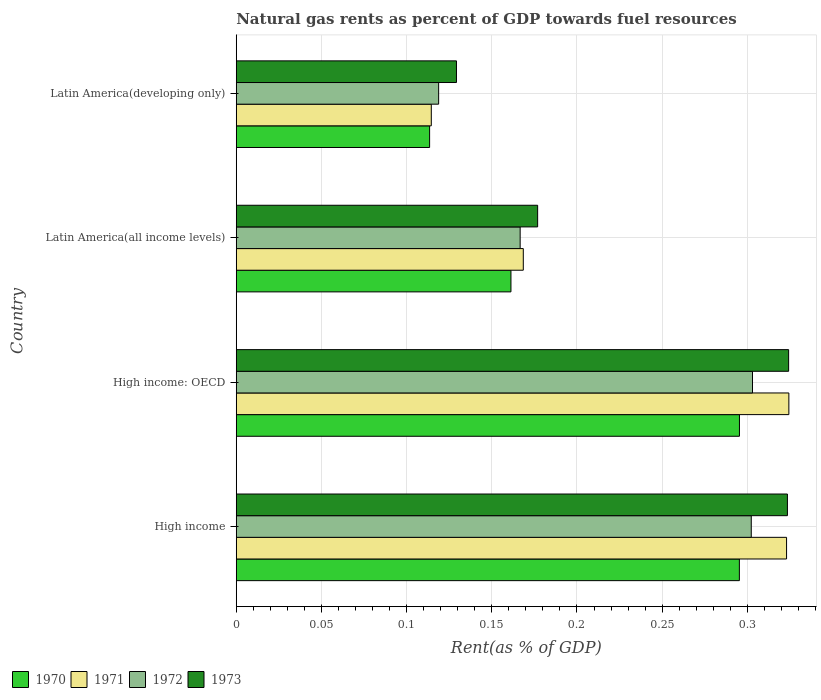How many different coloured bars are there?
Ensure brevity in your answer.  4. How many groups of bars are there?
Provide a succinct answer. 4. Are the number of bars on each tick of the Y-axis equal?
Your answer should be compact. Yes. How many bars are there on the 1st tick from the top?
Keep it short and to the point. 4. How many bars are there on the 4th tick from the bottom?
Your answer should be very brief. 4. In how many cases, is the number of bars for a given country not equal to the number of legend labels?
Make the answer very short. 0. What is the matural gas rent in 1970 in High income: OECD?
Your answer should be compact. 0.3. Across all countries, what is the maximum matural gas rent in 1972?
Make the answer very short. 0.3. Across all countries, what is the minimum matural gas rent in 1970?
Make the answer very short. 0.11. In which country was the matural gas rent in 1973 maximum?
Ensure brevity in your answer.  High income: OECD. In which country was the matural gas rent in 1970 minimum?
Your answer should be compact. Latin America(developing only). What is the total matural gas rent in 1972 in the graph?
Give a very brief answer. 0.89. What is the difference between the matural gas rent in 1972 in High income and that in Latin America(developing only)?
Your response must be concise. 0.18. What is the difference between the matural gas rent in 1972 in Latin America(all income levels) and the matural gas rent in 1971 in High income: OECD?
Your response must be concise. -0.16. What is the average matural gas rent in 1972 per country?
Keep it short and to the point. 0.22. What is the difference between the matural gas rent in 1970 and matural gas rent in 1971 in Latin America(developing only)?
Provide a succinct answer. -0. In how many countries, is the matural gas rent in 1971 greater than 0.28 %?
Provide a succinct answer. 2. What is the ratio of the matural gas rent in 1970 in High income to that in Latin America(developing only)?
Offer a very short reply. 2.6. Is the matural gas rent in 1971 in High income less than that in High income: OECD?
Keep it short and to the point. Yes. Is the difference between the matural gas rent in 1970 in High income: OECD and Latin America(developing only) greater than the difference between the matural gas rent in 1971 in High income: OECD and Latin America(developing only)?
Your answer should be compact. No. What is the difference between the highest and the second highest matural gas rent in 1973?
Your response must be concise. 0. What is the difference between the highest and the lowest matural gas rent in 1972?
Make the answer very short. 0.18. Is the sum of the matural gas rent in 1973 in High income and High income: OECD greater than the maximum matural gas rent in 1972 across all countries?
Offer a terse response. Yes. How many countries are there in the graph?
Your answer should be very brief. 4. Are the values on the major ticks of X-axis written in scientific E-notation?
Your answer should be compact. No. Does the graph contain any zero values?
Provide a succinct answer. No. Does the graph contain grids?
Give a very brief answer. Yes. How are the legend labels stacked?
Make the answer very short. Horizontal. What is the title of the graph?
Keep it short and to the point. Natural gas rents as percent of GDP towards fuel resources. Does "2013" appear as one of the legend labels in the graph?
Provide a succinct answer. No. What is the label or title of the X-axis?
Your response must be concise. Rent(as % of GDP). What is the label or title of the Y-axis?
Your answer should be very brief. Country. What is the Rent(as % of GDP) in 1970 in High income?
Provide a short and direct response. 0.3. What is the Rent(as % of GDP) in 1971 in High income?
Give a very brief answer. 0.32. What is the Rent(as % of GDP) in 1972 in High income?
Your response must be concise. 0.3. What is the Rent(as % of GDP) in 1973 in High income?
Give a very brief answer. 0.32. What is the Rent(as % of GDP) of 1970 in High income: OECD?
Make the answer very short. 0.3. What is the Rent(as % of GDP) of 1971 in High income: OECD?
Make the answer very short. 0.32. What is the Rent(as % of GDP) of 1972 in High income: OECD?
Ensure brevity in your answer.  0.3. What is the Rent(as % of GDP) in 1973 in High income: OECD?
Keep it short and to the point. 0.32. What is the Rent(as % of GDP) of 1970 in Latin America(all income levels)?
Provide a short and direct response. 0.16. What is the Rent(as % of GDP) in 1971 in Latin America(all income levels)?
Offer a terse response. 0.17. What is the Rent(as % of GDP) in 1972 in Latin America(all income levels)?
Make the answer very short. 0.17. What is the Rent(as % of GDP) of 1973 in Latin America(all income levels)?
Offer a terse response. 0.18. What is the Rent(as % of GDP) of 1970 in Latin America(developing only)?
Your answer should be very brief. 0.11. What is the Rent(as % of GDP) of 1971 in Latin America(developing only)?
Provide a short and direct response. 0.11. What is the Rent(as % of GDP) in 1972 in Latin America(developing only)?
Make the answer very short. 0.12. What is the Rent(as % of GDP) in 1973 in Latin America(developing only)?
Offer a terse response. 0.13. Across all countries, what is the maximum Rent(as % of GDP) in 1970?
Provide a short and direct response. 0.3. Across all countries, what is the maximum Rent(as % of GDP) in 1971?
Give a very brief answer. 0.32. Across all countries, what is the maximum Rent(as % of GDP) in 1972?
Your answer should be compact. 0.3. Across all countries, what is the maximum Rent(as % of GDP) of 1973?
Your response must be concise. 0.32. Across all countries, what is the minimum Rent(as % of GDP) of 1970?
Provide a succinct answer. 0.11. Across all countries, what is the minimum Rent(as % of GDP) in 1971?
Provide a succinct answer. 0.11. Across all countries, what is the minimum Rent(as % of GDP) of 1972?
Ensure brevity in your answer.  0.12. Across all countries, what is the minimum Rent(as % of GDP) of 1973?
Ensure brevity in your answer.  0.13. What is the total Rent(as % of GDP) of 1970 in the graph?
Provide a short and direct response. 0.87. What is the total Rent(as % of GDP) of 1971 in the graph?
Make the answer very short. 0.93. What is the total Rent(as % of GDP) of 1972 in the graph?
Offer a very short reply. 0.89. What is the total Rent(as % of GDP) of 1973 in the graph?
Offer a very short reply. 0.95. What is the difference between the Rent(as % of GDP) in 1971 in High income and that in High income: OECD?
Offer a terse response. -0. What is the difference between the Rent(as % of GDP) of 1972 in High income and that in High income: OECD?
Provide a succinct answer. -0. What is the difference between the Rent(as % of GDP) of 1973 in High income and that in High income: OECD?
Your response must be concise. -0. What is the difference between the Rent(as % of GDP) of 1970 in High income and that in Latin America(all income levels)?
Offer a very short reply. 0.13. What is the difference between the Rent(as % of GDP) in 1971 in High income and that in Latin America(all income levels)?
Your response must be concise. 0.15. What is the difference between the Rent(as % of GDP) of 1972 in High income and that in Latin America(all income levels)?
Make the answer very short. 0.14. What is the difference between the Rent(as % of GDP) of 1973 in High income and that in Latin America(all income levels)?
Ensure brevity in your answer.  0.15. What is the difference between the Rent(as % of GDP) of 1970 in High income and that in Latin America(developing only)?
Ensure brevity in your answer.  0.18. What is the difference between the Rent(as % of GDP) of 1971 in High income and that in Latin America(developing only)?
Offer a terse response. 0.21. What is the difference between the Rent(as % of GDP) of 1972 in High income and that in Latin America(developing only)?
Provide a short and direct response. 0.18. What is the difference between the Rent(as % of GDP) in 1973 in High income and that in Latin America(developing only)?
Make the answer very short. 0.19. What is the difference between the Rent(as % of GDP) of 1970 in High income: OECD and that in Latin America(all income levels)?
Give a very brief answer. 0.13. What is the difference between the Rent(as % of GDP) in 1971 in High income: OECD and that in Latin America(all income levels)?
Provide a short and direct response. 0.16. What is the difference between the Rent(as % of GDP) of 1972 in High income: OECD and that in Latin America(all income levels)?
Provide a short and direct response. 0.14. What is the difference between the Rent(as % of GDP) in 1973 in High income: OECD and that in Latin America(all income levels)?
Ensure brevity in your answer.  0.15. What is the difference between the Rent(as % of GDP) of 1970 in High income: OECD and that in Latin America(developing only)?
Make the answer very short. 0.18. What is the difference between the Rent(as % of GDP) of 1971 in High income: OECD and that in Latin America(developing only)?
Ensure brevity in your answer.  0.21. What is the difference between the Rent(as % of GDP) of 1972 in High income: OECD and that in Latin America(developing only)?
Make the answer very short. 0.18. What is the difference between the Rent(as % of GDP) of 1973 in High income: OECD and that in Latin America(developing only)?
Ensure brevity in your answer.  0.2. What is the difference between the Rent(as % of GDP) of 1970 in Latin America(all income levels) and that in Latin America(developing only)?
Make the answer very short. 0.05. What is the difference between the Rent(as % of GDP) of 1971 in Latin America(all income levels) and that in Latin America(developing only)?
Your response must be concise. 0.05. What is the difference between the Rent(as % of GDP) in 1972 in Latin America(all income levels) and that in Latin America(developing only)?
Keep it short and to the point. 0.05. What is the difference between the Rent(as % of GDP) in 1973 in Latin America(all income levels) and that in Latin America(developing only)?
Provide a succinct answer. 0.05. What is the difference between the Rent(as % of GDP) in 1970 in High income and the Rent(as % of GDP) in 1971 in High income: OECD?
Offer a terse response. -0.03. What is the difference between the Rent(as % of GDP) of 1970 in High income and the Rent(as % of GDP) of 1972 in High income: OECD?
Your response must be concise. -0.01. What is the difference between the Rent(as % of GDP) in 1970 in High income and the Rent(as % of GDP) in 1973 in High income: OECD?
Give a very brief answer. -0.03. What is the difference between the Rent(as % of GDP) of 1971 in High income and the Rent(as % of GDP) of 1973 in High income: OECD?
Keep it short and to the point. -0. What is the difference between the Rent(as % of GDP) of 1972 in High income and the Rent(as % of GDP) of 1973 in High income: OECD?
Your response must be concise. -0.02. What is the difference between the Rent(as % of GDP) in 1970 in High income and the Rent(as % of GDP) in 1971 in Latin America(all income levels)?
Provide a short and direct response. 0.13. What is the difference between the Rent(as % of GDP) of 1970 in High income and the Rent(as % of GDP) of 1972 in Latin America(all income levels)?
Provide a short and direct response. 0.13. What is the difference between the Rent(as % of GDP) in 1970 in High income and the Rent(as % of GDP) in 1973 in Latin America(all income levels)?
Your answer should be compact. 0.12. What is the difference between the Rent(as % of GDP) in 1971 in High income and the Rent(as % of GDP) in 1972 in Latin America(all income levels)?
Offer a terse response. 0.16. What is the difference between the Rent(as % of GDP) of 1971 in High income and the Rent(as % of GDP) of 1973 in Latin America(all income levels)?
Offer a very short reply. 0.15. What is the difference between the Rent(as % of GDP) in 1972 in High income and the Rent(as % of GDP) in 1973 in Latin America(all income levels)?
Provide a short and direct response. 0.13. What is the difference between the Rent(as % of GDP) of 1970 in High income and the Rent(as % of GDP) of 1971 in Latin America(developing only)?
Offer a very short reply. 0.18. What is the difference between the Rent(as % of GDP) of 1970 in High income and the Rent(as % of GDP) of 1972 in Latin America(developing only)?
Give a very brief answer. 0.18. What is the difference between the Rent(as % of GDP) in 1970 in High income and the Rent(as % of GDP) in 1973 in Latin America(developing only)?
Offer a terse response. 0.17. What is the difference between the Rent(as % of GDP) in 1971 in High income and the Rent(as % of GDP) in 1972 in Latin America(developing only)?
Your response must be concise. 0.2. What is the difference between the Rent(as % of GDP) of 1971 in High income and the Rent(as % of GDP) of 1973 in Latin America(developing only)?
Provide a succinct answer. 0.19. What is the difference between the Rent(as % of GDP) of 1972 in High income and the Rent(as % of GDP) of 1973 in Latin America(developing only)?
Make the answer very short. 0.17. What is the difference between the Rent(as % of GDP) of 1970 in High income: OECD and the Rent(as % of GDP) of 1971 in Latin America(all income levels)?
Ensure brevity in your answer.  0.13. What is the difference between the Rent(as % of GDP) in 1970 in High income: OECD and the Rent(as % of GDP) in 1972 in Latin America(all income levels)?
Your answer should be very brief. 0.13. What is the difference between the Rent(as % of GDP) in 1970 in High income: OECD and the Rent(as % of GDP) in 1973 in Latin America(all income levels)?
Your answer should be compact. 0.12. What is the difference between the Rent(as % of GDP) of 1971 in High income: OECD and the Rent(as % of GDP) of 1972 in Latin America(all income levels)?
Offer a terse response. 0.16. What is the difference between the Rent(as % of GDP) in 1971 in High income: OECD and the Rent(as % of GDP) in 1973 in Latin America(all income levels)?
Your answer should be compact. 0.15. What is the difference between the Rent(as % of GDP) in 1972 in High income: OECD and the Rent(as % of GDP) in 1973 in Latin America(all income levels)?
Provide a short and direct response. 0.13. What is the difference between the Rent(as % of GDP) in 1970 in High income: OECD and the Rent(as % of GDP) in 1971 in Latin America(developing only)?
Ensure brevity in your answer.  0.18. What is the difference between the Rent(as % of GDP) of 1970 in High income: OECD and the Rent(as % of GDP) of 1972 in Latin America(developing only)?
Keep it short and to the point. 0.18. What is the difference between the Rent(as % of GDP) of 1970 in High income: OECD and the Rent(as % of GDP) of 1973 in Latin America(developing only)?
Offer a very short reply. 0.17. What is the difference between the Rent(as % of GDP) of 1971 in High income: OECD and the Rent(as % of GDP) of 1972 in Latin America(developing only)?
Your answer should be compact. 0.21. What is the difference between the Rent(as % of GDP) in 1971 in High income: OECD and the Rent(as % of GDP) in 1973 in Latin America(developing only)?
Ensure brevity in your answer.  0.2. What is the difference between the Rent(as % of GDP) in 1972 in High income: OECD and the Rent(as % of GDP) in 1973 in Latin America(developing only)?
Give a very brief answer. 0.17. What is the difference between the Rent(as % of GDP) in 1970 in Latin America(all income levels) and the Rent(as % of GDP) in 1971 in Latin America(developing only)?
Provide a succinct answer. 0.05. What is the difference between the Rent(as % of GDP) in 1970 in Latin America(all income levels) and the Rent(as % of GDP) in 1972 in Latin America(developing only)?
Make the answer very short. 0.04. What is the difference between the Rent(as % of GDP) in 1970 in Latin America(all income levels) and the Rent(as % of GDP) in 1973 in Latin America(developing only)?
Keep it short and to the point. 0.03. What is the difference between the Rent(as % of GDP) of 1971 in Latin America(all income levels) and the Rent(as % of GDP) of 1972 in Latin America(developing only)?
Make the answer very short. 0.05. What is the difference between the Rent(as % of GDP) in 1971 in Latin America(all income levels) and the Rent(as % of GDP) in 1973 in Latin America(developing only)?
Give a very brief answer. 0.04. What is the difference between the Rent(as % of GDP) in 1972 in Latin America(all income levels) and the Rent(as % of GDP) in 1973 in Latin America(developing only)?
Provide a succinct answer. 0.04. What is the average Rent(as % of GDP) of 1970 per country?
Your answer should be very brief. 0.22. What is the average Rent(as % of GDP) of 1971 per country?
Make the answer very short. 0.23. What is the average Rent(as % of GDP) in 1972 per country?
Your answer should be compact. 0.22. What is the average Rent(as % of GDP) in 1973 per country?
Your response must be concise. 0.24. What is the difference between the Rent(as % of GDP) of 1970 and Rent(as % of GDP) of 1971 in High income?
Provide a short and direct response. -0.03. What is the difference between the Rent(as % of GDP) of 1970 and Rent(as % of GDP) of 1972 in High income?
Offer a terse response. -0.01. What is the difference between the Rent(as % of GDP) in 1970 and Rent(as % of GDP) in 1973 in High income?
Keep it short and to the point. -0.03. What is the difference between the Rent(as % of GDP) in 1971 and Rent(as % of GDP) in 1972 in High income?
Offer a very short reply. 0.02. What is the difference between the Rent(as % of GDP) of 1971 and Rent(as % of GDP) of 1973 in High income?
Provide a succinct answer. -0. What is the difference between the Rent(as % of GDP) of 1972 and Rent(as % of GDP) of 1973 in High income?
Offer a very short reply. -0.02. What is the difference between the Rent(as % of GDP) of 1970 and Rent(as % of GDP) of 1971 in High income: OECD?
Ensure brevity in your answer.  -0.03. What is the difference between the Rent(as % of GDP) in 1970 and Rent(as % of GDP) in 1972 in High income: OECD?
Your answer should be very brief. -0.01. What is the difference between the Rent(as % of GDP) in 1970 and Rent(as % of GDP) in 1973 in High income: OECD?
Your answer should be compact. -0.03. What is the difference between the Rent(as % of GDP) of 1971 and Rent(as % of GDP) of 1972 in High income: OECD?
Your answer should be compact. 0.02. What is the difference between the Rent(as % of GDP) of 1971 and Rent(as % of GDP) of 1973 in High income: OECD?
Keep it short and to the point. 0. What is the difference between the Rent(as % of GDP) of 1972 and Rent(as % of GDP) of 1973 in High income: OECD?
Your answer should be compact. -0.02. What is the difference between the Rent(as % of GDP) in 1970 and Rent(as % of GDP) in 1971 in Latin America(all income levels)?
Your answer should be very brief. -0.01. What is the difference between the Rent(as % of GDP) of 1970 and Rent(as % of GDP) of 1972 in Latin America(all income levels)?
Provide a succinct answer. -0.01. What is the difference between the Rent(as % of GDP) in 1970 and Rent(as % of GDP) in 1973 in Latin America(all income levels)?
Offer a terse response. -0.02. What is the difference between the Rent(as % of GDP) in 1971 and Rent(as % of GDP) in 1972 in Latin America(all income levels)?
Make the answer very short. 0. What is the difference between the Rent(as % of GDP) of 1971 and Rent(as % of GDP) of 1973 in Latin America(all income levels)?
Provide a short and direct response. -0.01. What is the difference between the Rent(as % of GDP) of 1972 and Rent(as % of GDP) of 1973 in Latin America(all income levels)?
Make the answer very short. -0.01. What is the difference between the Rent(as % of GDP) in 1970 and Rent(as % of GDP) in 1971 in Latin America(developing only)?
Give a very brief answer. -0. What is the difference between the Rent(as % of GDP) of 1970 and Rent(as % of GDP) of 1972 in Latin America(developing only)?
Make the answer very short. -0.01. What is the difference between the Rent(as % of GDP) in 1970 and Rent(as % of GDP) in 1973 in Latin America(developing only)?
Offer a terse response. -0.02. What is the difference between the Rent(as % of GDP) of 1971 and Rent(as % of GDP) of 1972 in Latin America(developing only)?
Your response must be concise. -0. What is the difference between the Rent(as % of GDP) in 1971 and Rent(as % of GDP) in 1973 in Latin America(developing only)?
Make the answer very short. -0.01. What is the difference between the Rent(as % of GDP) of 1972 and Rent(as % of GDP) of 1973 in Latin America(developing only)?
Offer a very short reply. -0.01. What is the ratio of the Rent(as % of GDP) of 1971 in High income to that in High income: OECD?
Offer a terse response. 1. What is the ratio of the Rent(as % of GDP) in 1973 in High income to that in High income: OECD?
Offer a terse response. 1. What is the ratio of the Rent(as % of GDP) of 1970 in High income to that in Latin America(all income levels)?
Your response must be concise. 1.83. What is the ratio of the Rent(as % of GDP) of 1971 in High income to that in Latin America(all income levels)?
Provide a succinct answer. 1.92. What is the ratio of the Rent(as % of GDP) of 1972 in High income to that in Latin America(all income levels)?
Ensure brevity in your answer.  1.81. What is the ratio of the Rent(as % of GDP) of 1973 in High income to that in Latin America(all income levels)?
Your response must be concise. 1.83. What is the ratio of the Rent(as % of GDP) of 1970 in High income to that in Latin America(developing only)?
Provide a short and direct response. 2.6. What is the ratio of the Rent(as % of GDP) of 1971 in High income to that in Latin America(developing only)?
Offer a terse response. 2.82. What is the ratio of the Rent(as % of GDP) of 1972 in High income to that in Latin America(developing only)?
Your response must be concise. 2.54. What is the ratio of the Rent(as % of GDP) of 1973 in High income to that in Latin America(developing only)?
Your answer should be compact. 2.5. What is the ratio of the Rent(as % of GDP) of 1970 in High income: OECD to that in Latin America(all income levels)?
Ensure brevity in your answer.  1.83. What is the ratio of the Rent(as % of GDP) of 1971 in High income: OECD to that in Latin America(all income levels)?
Your answer should be very brief. 1.93. What is the ratio of the Rent(as % of GDP) in 1972 in High income: OECD to that in Latin America(all income levels)?
Offer a very short reply. 1.82. What is the ratio of the Rent(as % of GDP) of 1973 in High income: OECD to that in Latin America(all income levels)?
Provide a short and direct response. 1.83. What is the ratio of the Rent(as % of GDP) of 1970 in High income: OECD to that in Latin America(developing only)?
Ensure brevity in your answer.  2.6. What is the ratio of the Rent(as % of GDP) in 1971 in High income: OECD to that in Latin America(developing only)?
Offer a terse response. 2.83. What is the ratio of the Rent(as % of GDP) of 1972 in High income: OECD to that in Latin America(developing only)?
Your answer should be very brief. 2.55. What is the ratio of the Rent(as % of GDP) in 1973 in High income: OECD to that in Latin America(developing only)?
Ensure brevity in your answer.  2.51. What is the ratio of the Rent(as % of GDP) in 1970 in Latin America(all income levels) to that in Latin America(developing only)?
Your answer should be very brief. 1.42. What is the ratio of the Rent(as % of GDP) in 1971 in Latin America(all income levels) to that in Latin America(developing only)?
Your answer should be very brief. 1.47. What is the ratio of the Rent(as % of GDP) in 1972 in Latin America(all income levels) to that in Latin America(developing only)?
Ensure brevity in your answer.  1.4. What is the ratio of the Rent(as % of GDP) of 1973 in Latin America(all income levels) to that in Latin America(developing only)?
Provide a succinct answer. 1.37. What is the difference between the highest and the second highest Rent(as % of GDP) of 1970?
Give a very brief answer. 0. What is the difference between the highest and the second highest Rent(as % of GDP) of 1971?
Keep it short and to the point. 0. What is the difference between the highest and the second highest Rent(as % of GDP) in 1972?
Offer a terse response. 0. What is the difference between the highest and the second highest Rent(as % of GDP) in 1973?
Your answer should be very brief. 0. What is the difference between the highest and the lowest Rent(as % of GDP) of 1970?
Your answer should be very brief. 0.18. What is the difference between the highest and the lowest Rent(as % of GDP) of 1971?
Ensure brevity in your answer.  0.21. What is the difference between the highest and the lowest Rent(as % of GDP) in 1972?
Your response must be concise. 0.18. What is the difference between the highest and the lowest Rent(as % of GDP) in 1973?
Give a very brief answer. 0.2. 